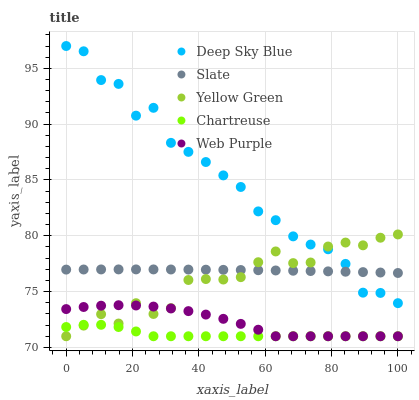Does Chartreuse have the minimum area under the curve?
Answer yes or no. Yes. Does Deep Sky Blue have the maximum area under the curve?
Answer yes or no. Yes. Does Slate have the minimum area under the curve?
Answer yes or no. No. Does Slate have the maximum area under the curve?
Answer yes or no. No. Is Slate the smoothest?
Answer yes or no. Yes. Is Deep Sky Blue the roughest?
Answer yes or no. Yes. Is Web Purple the smoothest?
Answer yes or no. No. Is Web Purple the roughest?
Answer yes or no. No. Does Chartreuse have the lowest value?
Answer yes or no. Yes. Does Slate have the lowest value?
Answer yes or no. No. Does Deep Sky Blue have the highest value?
Answer yes or no. Yes. Does Slate have the highest value?
Answer yes or no. No. Is Web Purple less than Slate?
Answer yes or no. Yes. Is Slate greater than Chartreuse?
Answer yes or no. Yes. Does Chartreuse intersect Web Purple?
Answer yes or no. Yes. Is Chartreuse less than Web Purple?
Answer yes or no. No. Is Chartreuse greater than Web Purple?
Answer yes or no. No. Does Web Purple intersect Slate?
Answer yes or no. No. 